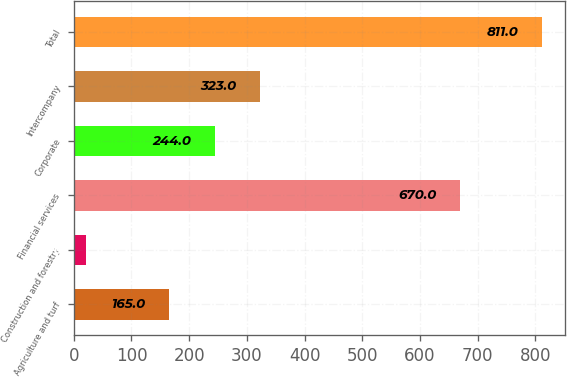Convert chart to OTSL. <chart><loc_0><loc_0><loc_500><loc_500><bar_chart><fcel>Agriculture and turf<fcel>Construction and forestry<fcel>Financial services<fcel>Corporate<fcel>Intercompany<fcel>Total<nl><fcel>165<fcel>21<fcel>670<fcel>244<fcel>323<fcel>811<nl></chart> 